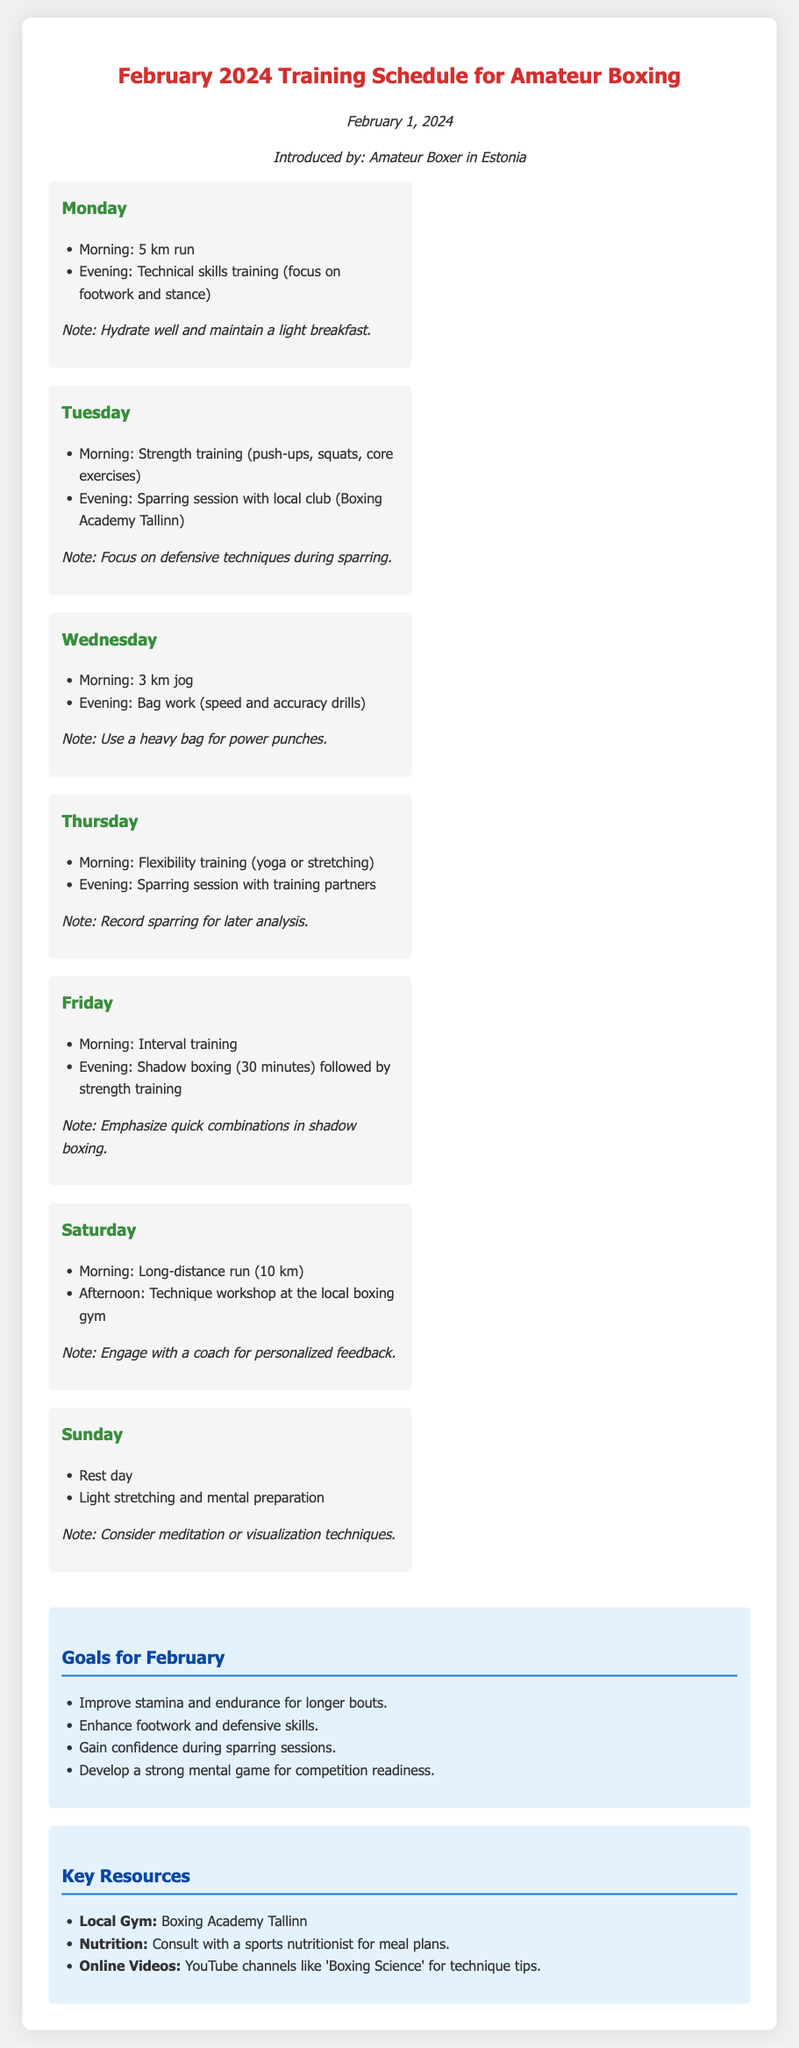What is the main purpose of this document? The document outlines the training schedule for amateur boxing for the month of February 2024.
Answer: February 2024 Training Schedule for Amateur Boxing Who introduced the memo? The memo is introduced by an amateur boxer in Estonia as stated in the document.
Answer: Amateur Boxer in Estonia How many kilometers is the long-distance run scheduled for Saturday? The long-distance run is specified to be 10 kilometers on Saturday in the document.
Answer: 10 km What type of training is scheduled for Tuesday evening? The document specifies that there is a sparring session with the local club on Tuesday evening.
Answer: Sparring session What is the focus of the morning workout on Monday? The morning workout on Monday focuses on a 5 km run according to the schedule in the document.
Answer: 5 km run What is the workout planned for Wednesday evening? The workout planned for Wednesday evening includes bag work with speed and accuracy drills.
Answer: Bag work What day is designated as a rest day? The document designates Sunday as a rest day.
Answer: Sunday What technique is emphasized in shadow boxing on Friday? The emphasis during shadow boxing on Friday is on quick combinations as highlighted in the memo.
Answer: Quick combinations What is suggested for mental preparation on Sunday? The document suggests considering meditation or visualization techniques for mental preparation on Sunday.
Answer: Meditation or visualization techniques 